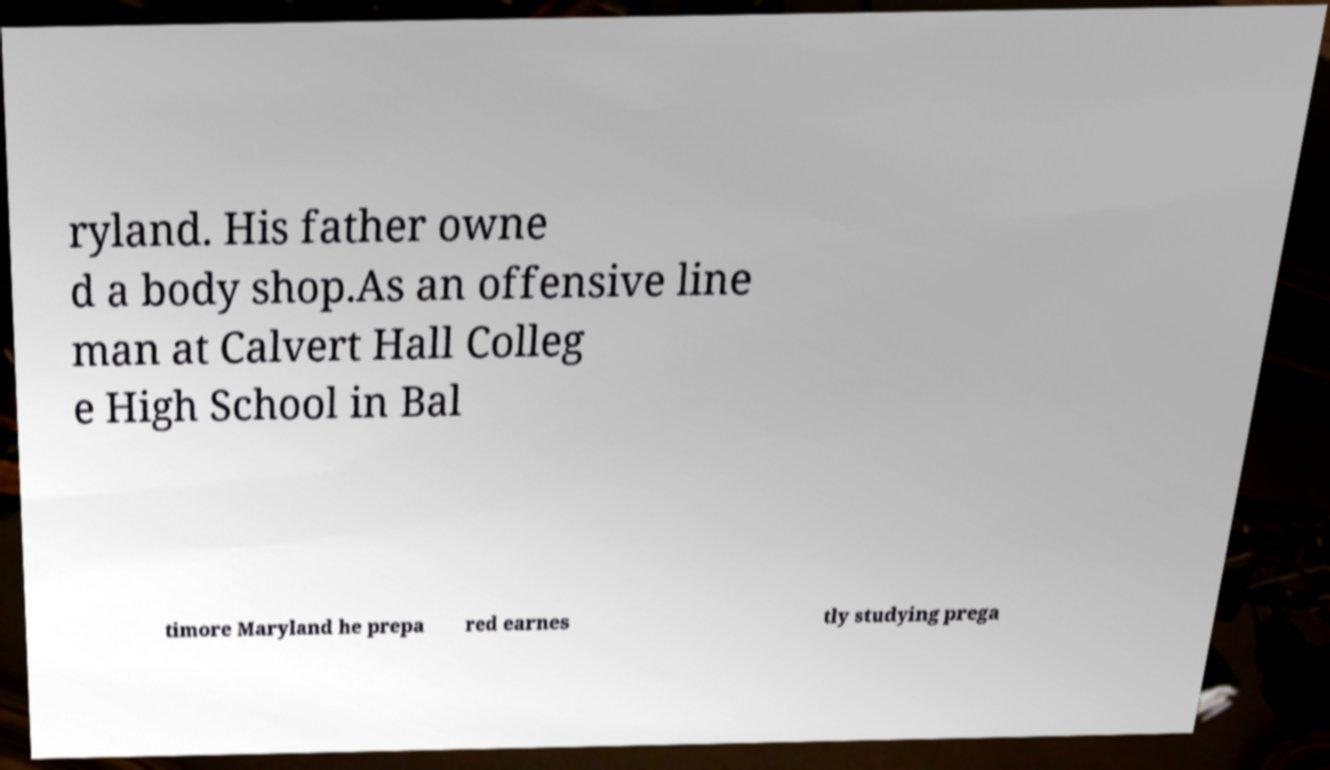There's text embedded in this image that I need extracted. Can you transcribe it verbatim? ryland. His father owne d a body shop.As an offensive line man at Calvert Hall Colleg e High School in Bal timore Maryland he prepa red earnes tly studying prega 